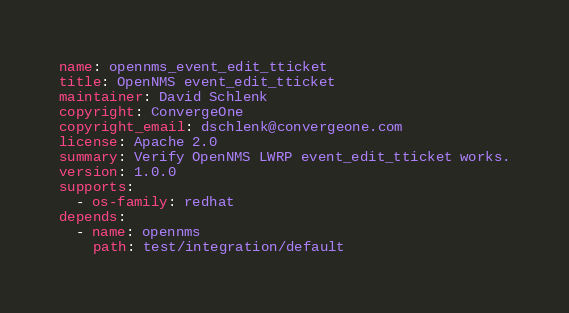Convert code to text. <code><loc_0><loc_0><loc_500><loc_500><_YAML_>name: opennms_event_edit_tticket
title: OpenNMS event_edit_tticket
maintainer: David Schlenk
copyright: ConvergeOne
copyright_email: dschlenk@convergeone.com
license: Apache 2.0
summary: Verify OpenNMS LWRP event_edit_tticket works.
version: 1.0.0
supports:
  - os-family: redhat
depends:
  - name: opennms
    path: test/integration/default
</code> 